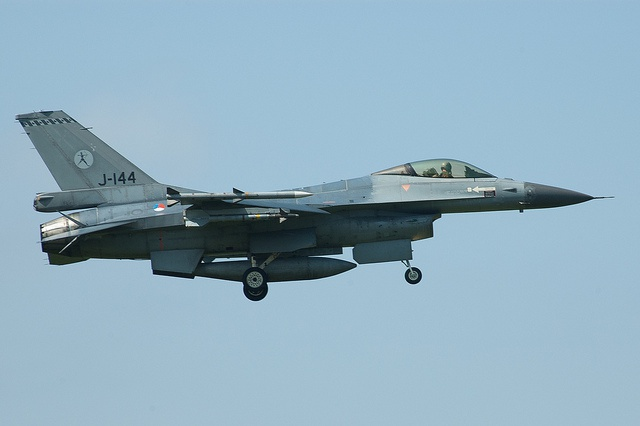Describe the objects in this image and their specific colors. I can see airplane in lightblue, black, gray, and darkgray tones and people in lightblue, darkgray, gray, black, and teal tones in this image. 